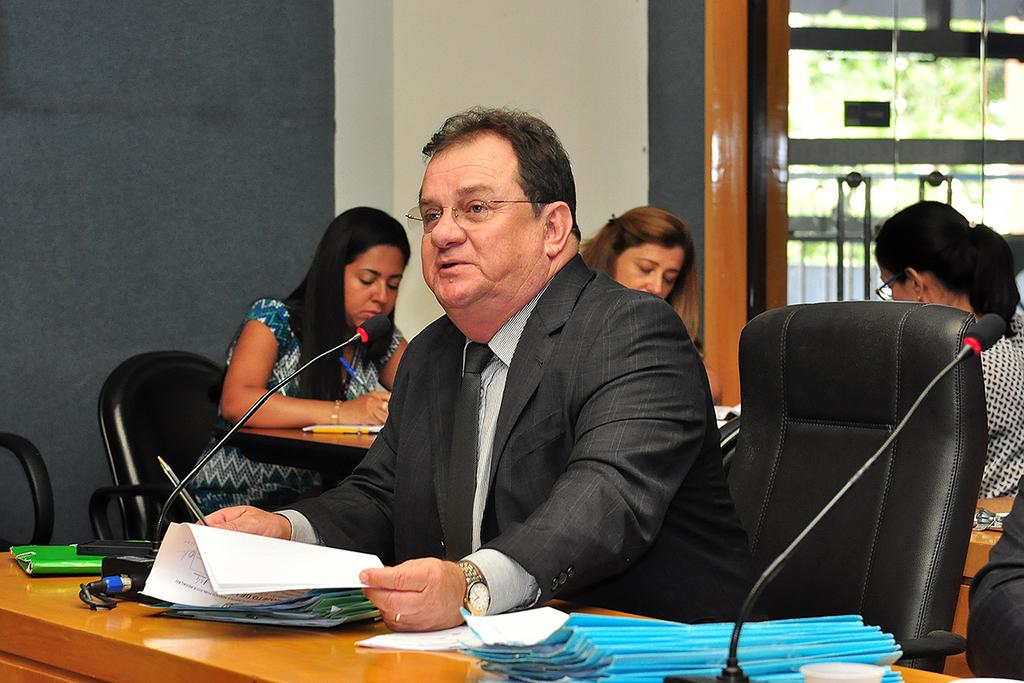What can be seen in the background of the image? There are trees in the background of the image. What are the people in the image doing? The people are sitting on chairs in the image. What is on the table in the image? There are files, a Mac computer, and papers on the table. What type of computer is on the table? There is a Mac computer on the table. How many children are playing in the mouth of the spring in the image? There are no children, mouth, or spring present in the image. 